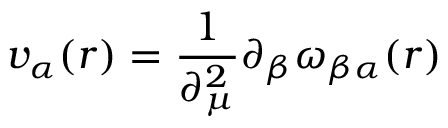Convert formula to latex. <formula><loc_0><loc_0><loc_500><loc_500>v _ { \alpha } ( r ) = \frac { 1 } { \partial _ { \mu } ^ { 2 } } \partial _ { \beta } \omega _ { \beta \alpha } ( r )</formula> 